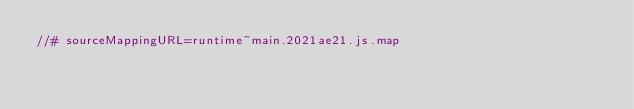<code> <loc_0><loc_0><loc_500><loc_500><_JavaScript_>//# sourceMappingURL=runtime~main.2021ae21.js.map</code> 